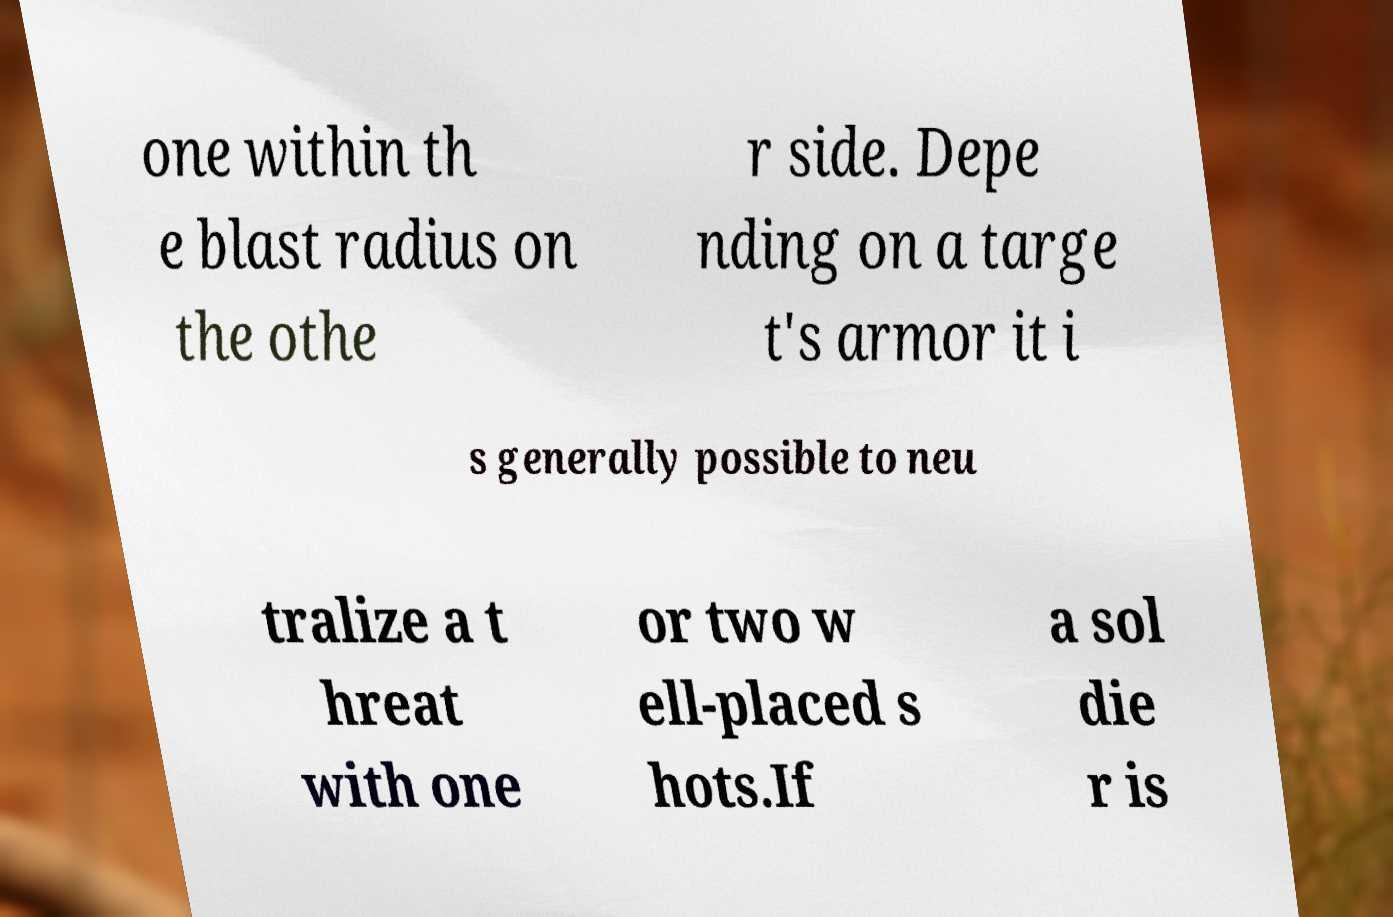Please read and relay the text visible in this image. What does it say? one within th e blast radius on the othe r side. Depe nding on a targe t's armor it i s generally possible to neu tralize a t hreat with one or two w ell-placed s hots.If a sol die r is 